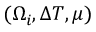<formula> <loc_0><loc_0><loc_500><loc_500>( \Omega _ { i } , \Delta T , \mu )</formula> 